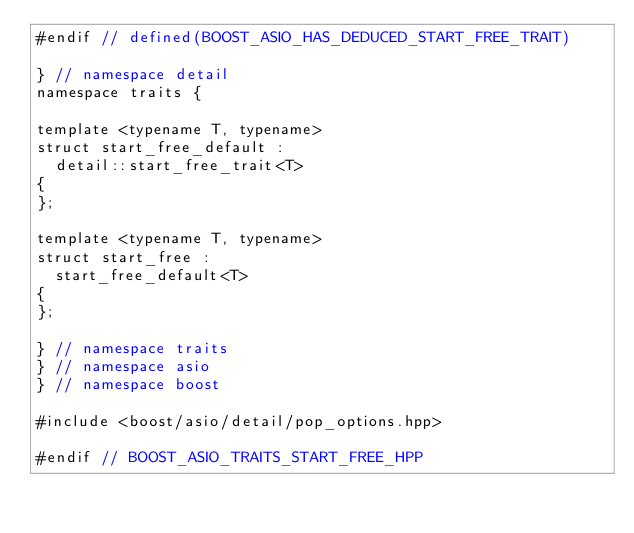Convert code to text. <code><loc_0><loc_0><loc_500><loc_500><_C++_>#endif // defined(BOOST_ASIO_HAS_DEDUCED_START_FREE_TRAIT)

} // namespace detail
namespace traits {

template <typename T, typename>
struct start_free_default :
  detail::start_free_trait<T>
{
};

template <typename T, typename>
struct start_free :
  start_free_default<T>
{
};

} // namespace traits
} // namespace asio
} // namespace boost

#include <boost/asio/detail/pop_options.hpp>

#endif // BOOST_ASIO_TRAITS_START_FREE_HPP
</code> 